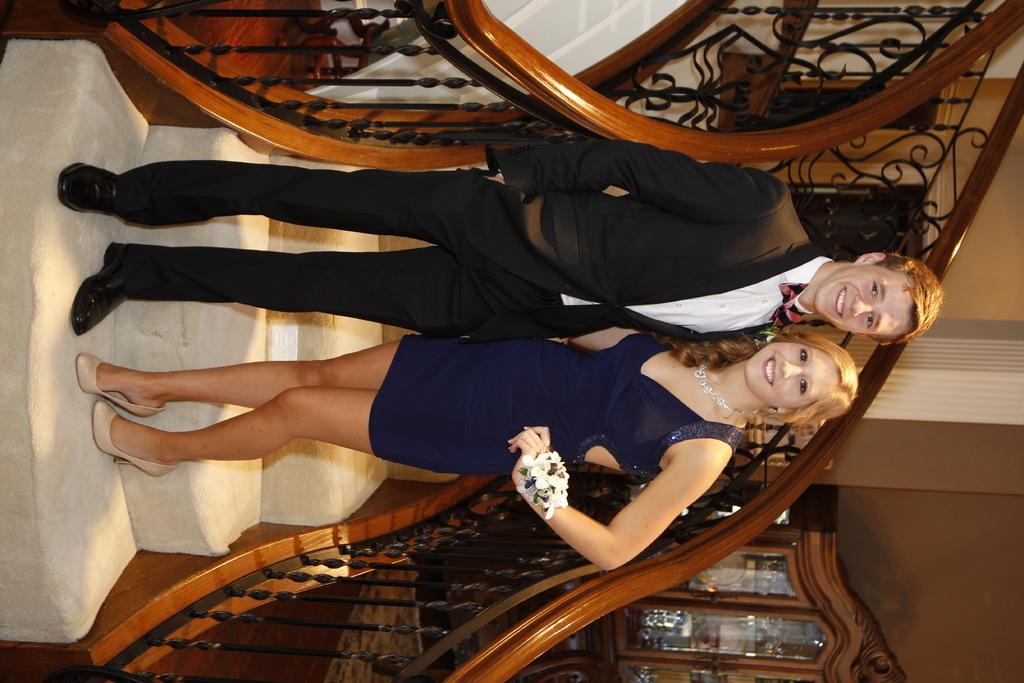In one or two sentences, can you explain what this image depicts? This is a rotated image. In this image we can see there is a couple standing on the stairs, beside the stairs there is a cupboard. In the background there is a wall. 